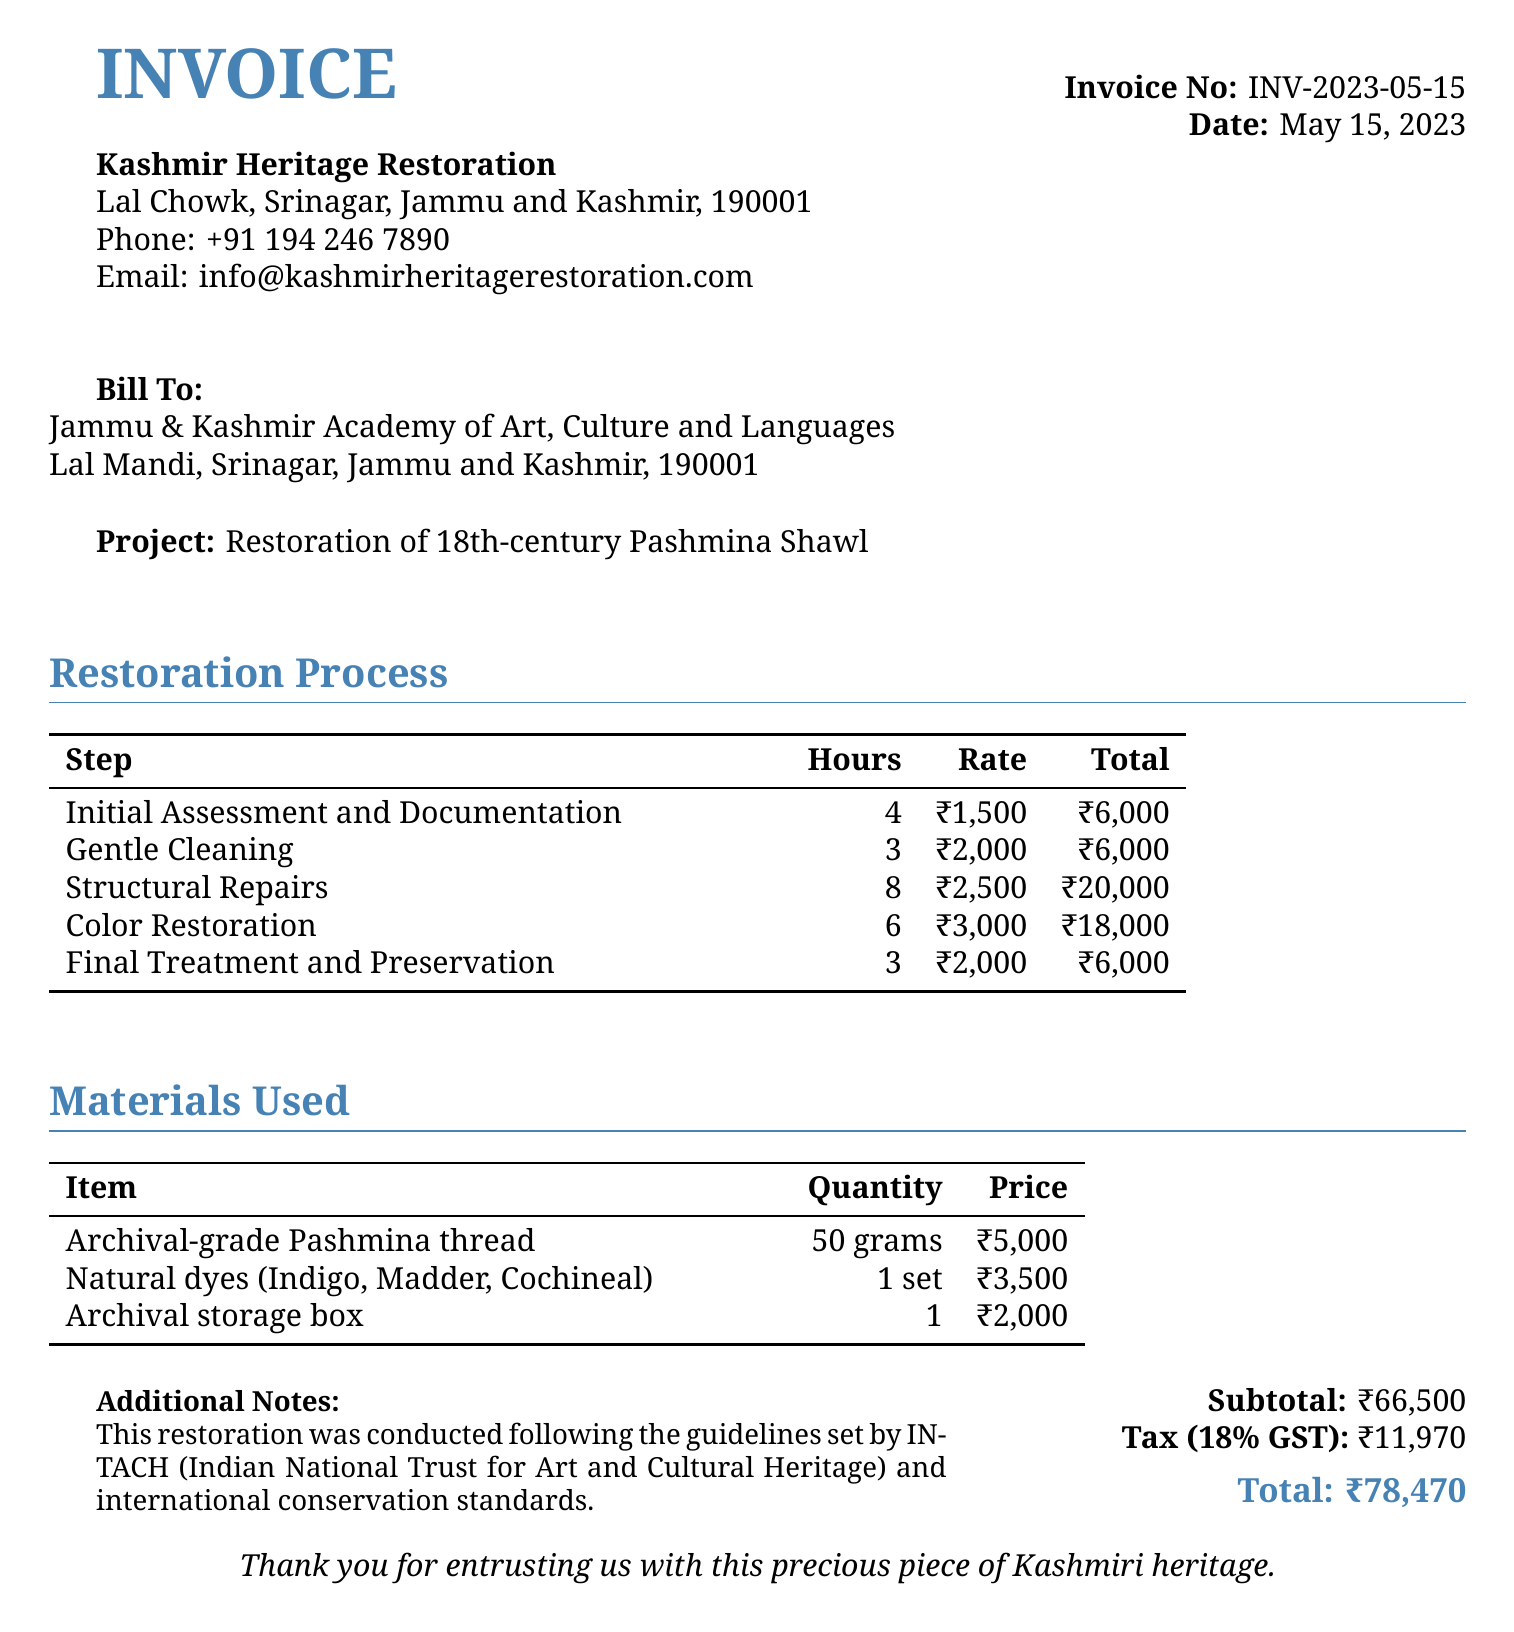What is the invoice number? The invoice number is specified in the document under "Invoice No."
Answer: INV-2023-05-15 What is the date of the invoice? The date of the invoice is provided in the document under "Date."
Answer: May 15, 2023 How many hours were spent on structural repairs? The number of hours for structural repairs is listed in the restoration process.
Answer: 8 What is the total cost for color restoration? The total cost for color restoration is calculated and listed in the restoration process table.
Answer: ₹18,000 What materials were used for color restoration? The document lists natural dyes used in the materials section.
Answer: Indigo, Madder, Cochineal What is the quantity of archival-grade Pashmina thread used? The quantity is specified in the materials used section of the document.
Answer: 50 grams What is the subtotal amount before tax? The subtotal is clearly stated in the total section of the document.
Answer: ₹66,500 What organization is the bill addressed to? The recipient of the bill is listed at the top of the document under "Bill To."
Answer: Jammu & Kashmir Academy of Art, Culture and Languages What percentage is the tax applied? The tax percentage is provided in the subtotal area of the invoice.
Answer: 18% 